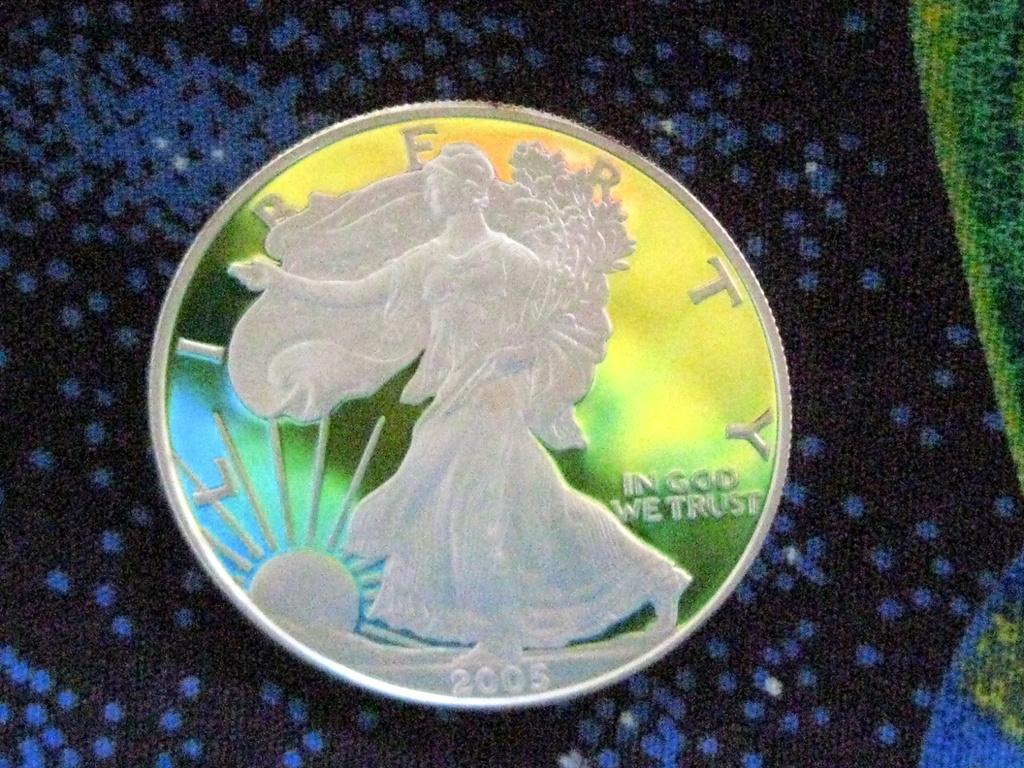Provide a one-sentence caption for the provided image. a shiny silver coin reading Liberty and In God We Trust. 